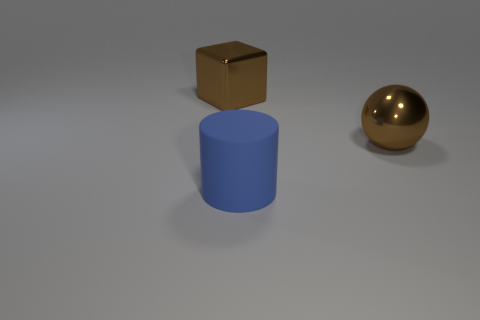There is a big cylinder; does it have the same color as the thing that is to the right of the rubber object?
Offer a terse response. No. Are there fewer shiny blocks behind the large brown metallic block than tiny metallic cubes?
Give a very brief answer. No. How many large blue objects are there?
Make the answer very short. 1. What is the shape of the metal object that is on the right side of the brown shiny object left of the big blue rubber object?
Offer a very short reply. Sphere. There is a blue thing; how many large shiny spheres are right of it?
Your response must be concise. 1. Is the material of the sphere the same as the brown block to the left of the blue rubber cylinder?
Offer a terse response. Yes. Are there any brown shiny spheres of the same size as the blue cylinder?
Offer a very short reply. Yes. Is the number of blue things that are to the left of the blue matte cylinder the same as the number of small green things?
Provide a succinct answer. Yes. What size is the brown metal cube?
Your answer should be very brief. Large. There is a rubber object that is in front of the brown block; how many metallic objects are in front of it?
Offer a terse response. 0. 